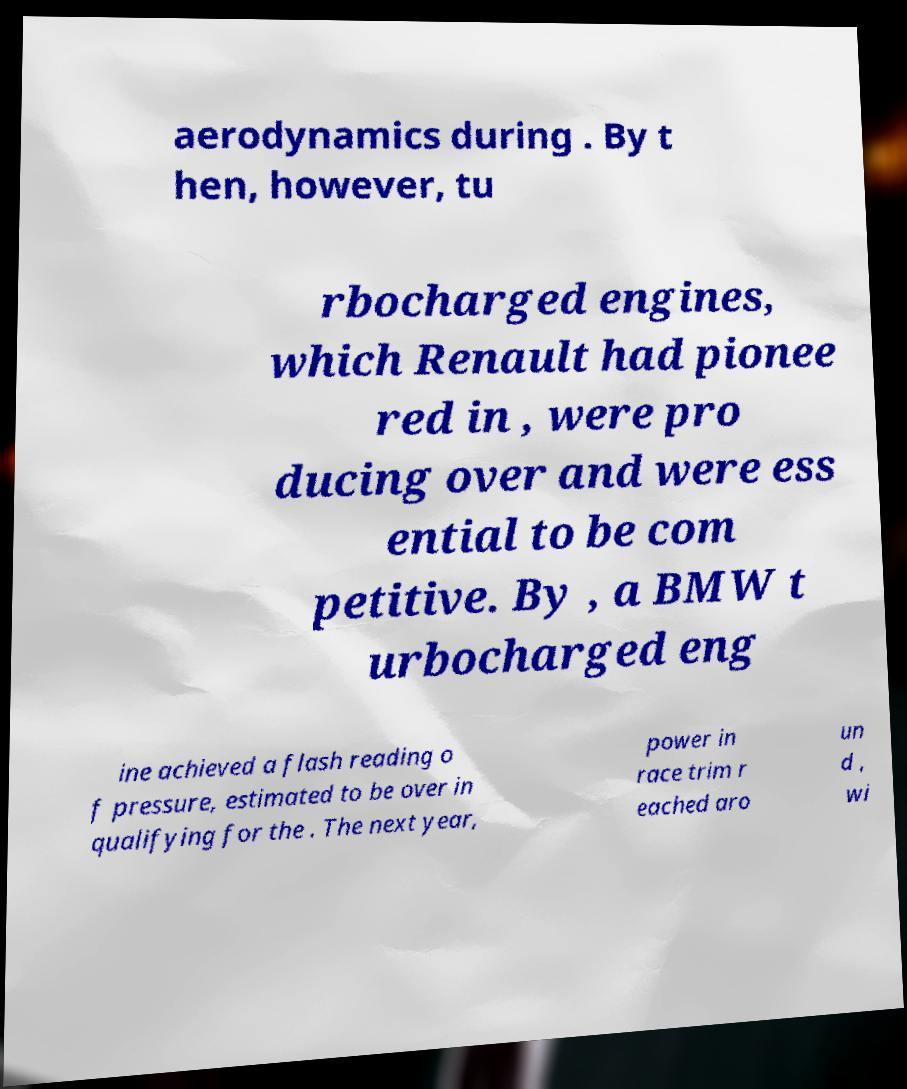Could you extract and type out the text from this image? aerodynamics during . By t hen, however, tu rbocharged engines, which Renault had pionee red in , were pro ducing over and were ess ential to be com petitive. By , a BMW t urbocharged eng ine achieved a flash reading o f pressure, estimated to be over in qualifying for the . The next year, power in race trim r eached aro un d , wi 